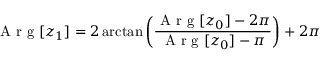Convert formula to latex. <formula><loc_0><loc_0><loc_500><loc_500>A r g [ z _ { 1 } ] = 2 \arctan \left ( \frac { A r g [ z _ { 0 } ] - 2 \pi } { A r g [ z _ { 0 } ] - \pi } \right ) + 2 \pi</formula> 